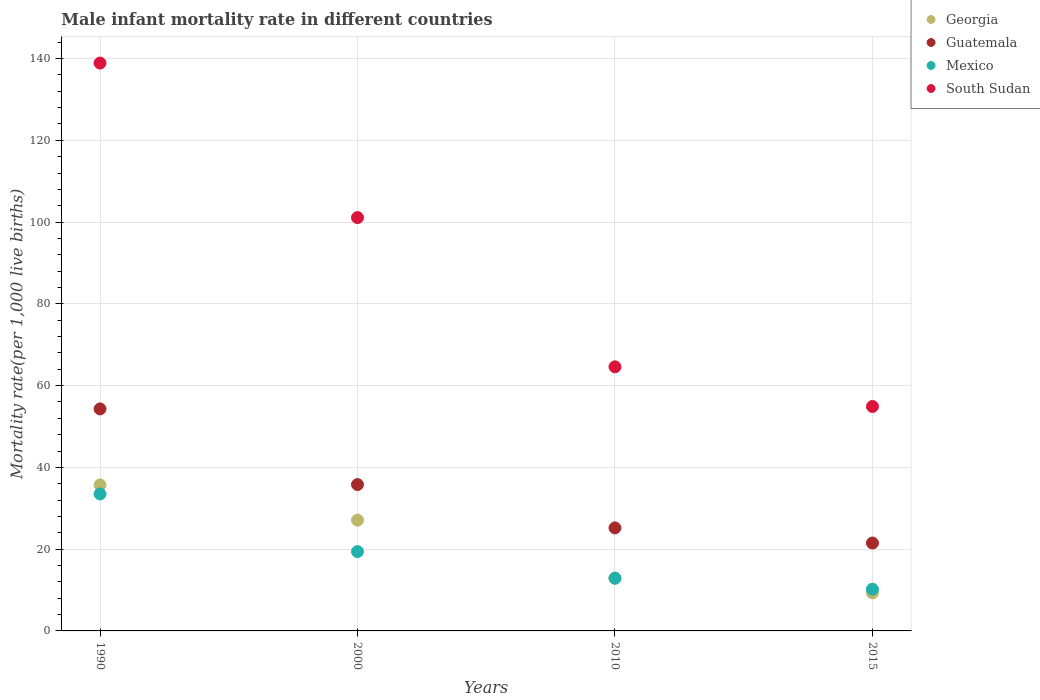What is the male infant mortality rate in Mexico in 1990?
Make the answer very short. 33.5. Across all years, what is the maximum male infant mortality rate in Guatemala?
Your answer should be very brief. 54.3. Across all years, what is the minimum male infant mortality rate in Guatemala?
Your response must be concise. 21.5. In which year was the male infant mortality rate in South Sudan maximum?
Offer a terse response. 1990. In which year was the male infant mortality rate in Mexico minimum?
Offer a very short reply. 2015. What is the total male infant mortality rate in South Sudan in the graph?
Offer a very short reply. 359.5. What is the difference between the male infant mortality rate in Mexico in 2000 and that in 2015?
Offer a terse response. 9.2. What is the difference between the male infant mortality rate in Georgia in 2015 and the male infant mortality rate in Mexico in 1990?
Provide a short and direct response. -24.2. In the year 1990, what is the difference between the male infant mortality rate in Guatemala and male infant mortality rate in Mexico?
Your answer should be compact. 20.8. What is the ratio of the male infant mortality rate in South Sudan in 2000 to that in 2015?
Ensure brevity in your answer.  1.84. Is the male infant mortality rate in Georgia in 1990 less than that in 2000?
Your answer should be very brief. No. Is the difference between the male infant mortality rate in Guatemala in 1990 and 2015 greater than the difference between the male infant mortality rate in Mexico in 1990 and 2015?
Offer a very short reply. Yes. What is the difference between the highest and the second highest male infant mortality rate in Guatemala?
Give a very brief answer. 18.5. What is the difference between the highest and the lowest male infant mortality rate in Guatemala?
Ensure brevity in your answer.  32.8. Is the sum of the male infant mortality rate in Guatemala in 2000 and 2010 greater than the maximum male infant mortality rate in South Sudan across all years?
Keep it short and to the point. No. Is it the case that in every year, the sum of the male infant mortality rate in Mexico and male infant mortality rate in Guatemala  is greater than the sum of male infant mortality rate in South Sudan and male infant mortality rate in Georgia?
Your response must be concise. No. Is it the case that in every year, the sum of the male infant mortality rate in Georgia and male infant mortality rate in Mexico  is greater than the male infant mortality rate in Guatemala?
Keep it short and to the point. No. Does the male infant mortality rate in Georgia monotonically increase over the years?
Ensure brevity in your answer.  No. Is the male infant mortality rate in Georgia strictly greater than the male infant mortality rate in South Sudan over the years?
Provide a succinct answer. No. Is the male infant mortality rate in Georgia strictly less than the male infant mortality rate in Guatemala over the years?
Your answer should be very brief. Yes. How many dotlines are there?
Provide a succinct answer. 4. What is the difference between two consecutive major ticks on the Y-axis?
Provide a succinct answer. 20. Does the graph contain grids?
Provide a short and direct response. Yes. How many legend labels are there?
Your answer should be very brief. 4. What is the title of the graph?
Make the answer very short. Male infant mortality rate in different countries. What is the label or title of the Y-axis?
Ensure brevity in your answer.  Mortality rate(per 1,0 live births). What is the Mortality rate(per 1,000 live births) of Georgia in 1990?
Provide a succinct answer. 35.7. What is the Mortality rate(per 1,000 live births) of Guatemala in 1990?
Provide a succinct answer. 54.3. What is the Mortality rate(per 1,000 live births) in Mexico in 1990?
Keep it short and to the point. 33.5. What is the Mortality rate(per 1,000 live births) in South Sudan in 1990?
Your answer should be very brief. 138.9. What is the Mortality rate(per 1,000 live births) in Georgia in 2000?
Your response must be concise. 27.1. What is the Mortality rate(per 1,000 live births) of Guatemala in 2000?
Give a very brief answer. 35.8. What is the Mortality rate(per 1,000 live births) of Mexico in 2000?
Provide a succinct answer. 19.4. What is the Mortality rate(per 1,000 live births) in South Sudan in 2000?
Your response must be concise. 101.1. What is the Mortality rate(per 1,000 live births) in Guatemala in 2010?
Your answer should be very brief. 25.2. What is the Mortality rate(per 1,000 live births) of South Sudan in 2010?
Make the answer very short. 64.6. What is the Mortality rate(per 1,000 live births) in Georgia in 2015?
Offer a terse response. 9.3. What is the Mortality rate(per 1,000 live births) of Guatemala in 2015?
Provide a succinct answer. 21.5. What is the Mortality rate(per 1,000 live births) of South Sudan in 2015?
Make the answer very short. 54.9. Across all years, what is the maximum Mortality rate(per 1,000 live births) of Georgia?
Ensure brevity in your answer.  35.7. Across all years, what is the maximum Mortality rate(per 1,000 live births) in Guatemala?
Your answer should be compact. 54.3. Across all years, what is the maximum Mortality rate(per 1,000 live births) in Mexico?
Your answer should be very brief. 33.5. Across all years, what is the maximum Mortality rate(per 1,000 live births) of South Sudan?
Your answer should be very brief. 138.9. Across all years, what is the minimum Mortality rate(per 1,000 live births) of South Sudan?
Provide a short and direct response. 54.9. What is the total Mortality rate(per 1,000 live births) of Georgia in the graph?
Keep it short and to the point. 85. What is the total Mortality rate(per 1,000 live births) of Guatemala in the graph?
Ensure brevity in your answer.  136.8. What is the total Mortality rate(per 1,000 live births) in South Sudan in the graph?
Ensure brevity in your answer.  359.5. What is the difference between the Mortality rate(per 1,000 live births) of Mexico in 1990 and that in 2000?
Keep it short and to the point. 14.1. What is the difference between the Mortality rate(per 1,000 live births) in South Sudan in 1990 and that in 2000?
Keep it short and to the point. 37.8. What is the difference between the Mortality rate(per 1,000 live births) of Georgia in 1990 and that in 2010?
Provide a succinct answer. 22.8. What is the difference between the Mortality rate(per 1,000 live births) in Guatemala in 1990 and that in 2010?
Offer a very short reply. 29.1. What is the difference between the Mortality rate(per 1,000 live births) in Mexico in 1990 and that in 2010?
Provide a short and direct response. 20.6. What is the difference between the Mortality rate(per 1,000 live births) in South Sudan in 1990 and that in 2010?
Offer a terse response. 74.3. What is the difference between the Mortality rate(per 1,000 live births) of Georgia in 1990 and that in 2015?
Your response must be concise. 26.4. What is the difference between the Mortality rate(per 1,000 live births) of Guatemala in 1990 and that in 2015?
Offer a very short reply. 32.8. What is the difference between the Mortality rate(per 1,000 live births) of Mexico in 1990 and that in 2015?
Your response must be concise. 23.3. What is the difference between the Mortality rate(per 1,000 live births) in South Sudan in 1990 and that in 2015?
Keep it short and to the point. 84. What is the difference between the Mortality rate(per 1,000 live births) in Guatemala in 2000 and that in 2010?
Offer a terse response. 10.6. What is the difference between the Mortality rate(per 1,000 live births) in South Sudan in 2000 and that in 2010?
Offer a very short reply. 36.5. What is the difference between the Mortality rate(per 1,000 live births) in Mexico in 2000 and that in 2015?
Provide a short and direct response. 9.2. What is the difference between the Mortality rate(per 1,000 live births) in South Sudan in 2000 and that in 2015?
Your answer should be very brief. 46.2. What is the difference between the Mortality rate(per 1,000 live births) of Georgia in 2010 and that in 2015?
Provide a succinct answer. 3.6. What is the difference between the Mortality rate(per 1,000 live births) of Guatemala in 2010 and that in 2015?
Offer a terse response. 3.7. What is the difference between the Mortality rate(per 1,000 live births) in Mexico in 2010 and that in 2015?
Keep it short and to the point. 2.7. What is the difference between the Mortality rate(per 1,000 live births) of Georgia in 1990 and the Mortality rate(per 1,000 live births) of Mexico in 2000?
Keep it short and to the point. 16.3. What is the difference between the Mortality rate(per 1,000 live births) of Georgia in 1990 and the Mortality rate(per 1,000 live births) of South Sudan in 2000?
Offer a very short reply. -65.4. What is the difference between the Mortality rate(per 1,000 live births) of Guatemala in 1990 and the Mortality rate(per 1,000 live births) of Mexico in 2000?
Offer a very short reply. 34.9. What is the difference between the Mortality rate(per 1,000 live births) in Guatemala in 1990 and the Mortality rate(per 1,000 live births) in South Sudan in 2000?
Your answer should be compact. -46.8. What is the difference between the Mortality rate(per 1,000 live births) in Mexico in 1990 and the Mortality rate(per 1,000 live births) in South Sudan in 2000?
Make the answer very short. -67.6. What is the difference between the Mortality rate(per 1,000 live births) in Georgia in 1990 and the Mortality rate(per 1,000 live births) in Mexico in 2010?
Your answer should be compact. 22.8. What is the difference between the Mortality rate(per 1,000 live births) of Georgia in 1990 and the Mortality rate(per 1,000 live births) of South Sudan in 2010?
Keep it short and to the point. -28.9. What is the difference between the Mortality rate(per 1,000 live births) in Guatemala in 1990 and the Mortality rate(per 1,000 live births) in Mexico in 2010?
Your response must be concise. 41.4. What is the difference between the Mortality rate(per 1,000 live births) in Guatemala in 1990 and the Mortality rate(per 1,000 live births) in South Sudan in 2010?
Your answer should be very brief. -10.3. What is the difference between the Mortality rate(per 1,000 live births) of Mexico in 1990 and the Mortality rate(per 1,000 live births) of South Sudan in 2010?
Provide a short and direct response. -31.1. What is the difference between the Mortality rate(per 1,000 live births) in Georgia in 1990 and the Mortality rate(per 1,000 live births) in Guatemala in 2015?
Your answer should be very brief. 14.2. What is the difference between the Mortality rate(per 1,000 live births) in Georgia in 1990 and the Mortality rate(per 1,000 live births) in South Sudan in 2015?
Keep it short and to the point. -19.2. What is the difference between the Mortality rate(per 1,000 live births) in Guatemala in 1990 and the Mortality rate(per 1,000 live births) in Mexico in 2015?
Your response must be concise. 44.1. What is the difference between the Mortality rate(per 1,000 live births) in Guatemala in 1990 and the Mortality rate(per 1,000 live births) in South Sudan in 2015?
Ensure brevity in your answer.  -0.6. What is the difference between the Mortality rate(per 1,000 live births) of Mexico in 1990 and the Mortality rate(per 1,000 live births) of South Sudan in 2015?
Provide a succinct answer. -21.4. What is the difference between the Mortality rate(per 1,000 live births) in Georgia in 2000 and the Mortality rate(per 1,000 live births) in South Sudan in 2010?
Your answer should be compact. -37.5. What is the difference between the Mortality rate(per 1,000 live births) in Guatemala in 2000 and the Mortality rate(per 1,000 live births) in Mexico in 2010?
Your response must be concise. 22.9. What is the difference between the Mortality rate(per 1,000 live births) of Guatemala in 2000 and the Mortality rate(per 1,000 live births) of South Sudan in 2010?
Keep it short and to the point. -28.8. What is the difference between the Mortality rate(per 1,000 live births) in Mexico in 2000 and the Mortality rate(per 1,000 live births) in South Sudan in 2010?
Provide a short and direct response. -45.2. What is the difference between the Mortality rate(per 1,000 live births) in Georgia in 2000 and the Mortality rate(per 1,000 live births) in South Sudan in 2015?
Your response must be concise. -27.8. What is the difference between the Mortality rate(per 1,000 live births) in Guatemala in 2000 and the Mortality rate(per 1,000 live births) in Mexico in 2015?
Offer a very short reply. 25.6. What is the difference between the Mortality rate(per 1,000 live births) of Guatemala in 2000 and the Mortality rate(per 1,000 live births) of South Sudan in 2015?
Your answer should be very brief. -19.1. What is the difference between the Mortality rate(per 1,000 live births) of Mexico in 2000 and the Mortality rate(per 1,000 live births) of South Sudan in 2015?
Offer a very short reply. -35.5. What is the difference between the Mortality rate(per 1,000 live births) in Georgia in 2010 and the Mortality rate(per 1,000 live births) in Guatemala in 2015?
Keep it short and to the point. -8.6. What is the difference between the Mortality rate(per 1,000 live births) in Georgia in 2010 and the Mortality rate(per 1,000 live births) in South Sudan in 2015?
Provide a short and direct response. -42. What is the difference between the Mortality rate(per 1,000 live births) of Guatemala in 2010 and the Mortality rate(per 1,000 live births) of South Sudan in 2015?
Your response must be concise. -29.7. What is the difference between the Mortality rate(per 1,000 live births) in Mexico in 2010 and the Mortality rate(per 1,000 live births) in South Sudan in 2015?
Provide a short and direct response. -42. What is the average Mortality rate(per 1,000 live births) in Georgia per year?
Offer a terse response. 21.25. What is the average Mortality rate(per 1,000 live births) of Guatemala per year?
Provide a short and direct response. 34.2. What is the average Mortality rate(per 1,000 live births) of Mexico per year?
Your response must be concise. 19. What is the average Mortality rate(per 1,000 live births) of South Sudan per year?
Your answer should be very brief. 89.88. In the year 1990, what is the difference between the Mortality rate(per 1,000 live births) in Georgia and Mortality rate(per 1,000 live births) in Guatemala?
Give a very brief answer. -18.6. In the year 1990, what is the difference between the Mortality rate(per 1,000 live births) in Georgia and Mortality rate(per 1,000 live births) in Mexico?
Your response must be concise. 2.2. In the year 1990, what is the difference between the Mortality rate(per 1,000 live births) in Georgia and Mortality rate(per 1,000 live births) in South Sudan?
Offer a very short reply. -103.2. In the year 1990, what is the difference between the Mortality rate(per 1,000 live births) of Guatemala and Mortality rate(per 1,000 live births) of Mexico?
Your answer should be compact. 20.8. In the year 1990, what is the difference between the Mortality rate(per 1,000 live births) in Guatemala and Mortality rate(per 1,000 live births) in South Sudan?
Ensure brevity in your answer.  -84.6. In the year 1990, what is the difference between the Mortality rate(per 1,000 live births) in Mexico and Mortality rate(per 1,000 live births) in South Sudan?
Give a very brief answer. -105.4. In the year 2000, what is the difference between the Mortality rate(per 1,000 live births) of Georgia and Mortality rate(per 1,000 live births) of Guatemala?
Provide a short and direct response. -8.7. In the year 2000, what is the difference between the Mortality rate(per 1,000 live births) of Georgia and Mortality rate(per 1,000 live births) of South Sudan?
Give a very brief answer. -74. In the year 2000, what is the difference between the Mortality rate(per 1,000 live births) in Guatemala and Mortality rate(per 1,000 live births) in South Sudan?
Give a very brief answer. -65.3. In the year 2000, what is the difference between the Mortality rate(per 1,000 live births) in Mexico and Mortality rate(per 1,000 live births) in South Sudan?
Ensure brevity in your answer.  -81.7. In the year 2010, what is the difference between the Mortality rate(per 1,000 live births) in Georgia and Mortality rate(per 1,000 live births) in Guatemala?
Keep it short and to the point. -12.3. In the year 2010, what is the difference between the Mortality rate(per 1,000 live births) of Georgia and Mortality rate(per 1,000 live births) of South Sudan?
Your answer should be compact. -51.7. In the year 2010, what is the difference between the Mortality rate(per 1,000 live births) in Guatemala and Mortality rate(per 1,000 live births) in Mexico?
Offer a terse response. 12.3. In the year 2010, what is the difference between the Mortality rate(per 1,000 live births) of Guatemala and Mortality rate(per 1,000 live births) of South Sudan?
Your response must be concise. -39.4. In the year 2010, what is the difference between the Mortality rate(per 1,000 live births) in Mexico and Mortality rate(per 1,000 live births) in South Sudan?
Offer a very short reply. -51.7. In the year 2015, what is the difference between the Mortality rate(per 1,000 live births) of Georgia and Mortality rate(per 1,000 live births) of Guatemala?
Ensure brevity in your answer.  -12.2. In the year 2015, what is the difference between the Mortality rate(per 1,000 live births) of Georgia and Mortality rate(per 1,000 live births) of South Sudan?
Keep it short and to the point. -45.6. In the year 2015, what is the difference between the Mortality rate(per 1,000 live births) of Guatemala and Mortality rate(per 1,000 live births) of Mexico?
Ensure brevity in your answer.  11.3. In the year 2015, what is the difference between the Mortality rate(per 1,000 live births) of Guatemala and Mortality rate(per 1,000 live births) of South Sudan?
Offer a terse response. -33.4. In the year 2015, what is the difference between the Mortality rate(per 1,000 live births) in Mexico and Mortality rate(per 1,000 live births) in South Sudan?
Your response must be concise. -44.7. What is the ratio of the Mortality rate(per 1,000 live births) of Georgia in 1990 to that in 2000?
Your answer should be very brief. 1.32. What is the ratio of the Mortality rate(per 1,000 live births) of Guatemala in 1990 to that in 2000?
Your answer should be compact. 1.52. What is the ratio of the Mortality rate(per 1,000 live births) in Mexico in 1990 to that in 2000?
Offer a very short reply. 1.73. What is the ratio of the Mortality rate(per 1,000 live births) in South Sudan in 1990 to that in 2000?
Offer a very short reply. 1.37. What is the ratio of the Mortality rate(per 1,000 live births) of Georgia in 1990 to that in 2010?
Keep it short and to the point. 2.77. What is the ratio of the Mortality rate(per 1,000 live births) in Guatemala in 1990 to that in 2010?
Give a very brief answer. 2.15. What is the ratio of the Mortality rate(per 1,000 live births) of Mexico in 1990 to that in 2010?
Ensure brevity in your answer.  2.6. What is the ratio of the Mortality rate(per 1,000 live births) in South Sudan in 1990 to that in 2010?
Your response must be concise. 2.15. What is the ratio of the Mortality rate(per 1,000 live births) of Georgia in 1990 to that in 2015?
Your answer should be compact. 3.84. What is the ratio of the Mortality rate(per 1,000 live births) in Guatemala in 1990 to that in 2015?
Your answer should be compact. 2.53. What is the ratio of the Mortality rate(per 1,000 live births) of Mexico in 1990 to that in 2015?
Make the answer very short. 3.28. What is the ratio of the Mortality rate(per 1,000 live births) of South Sudan in 1990 to that in 2015?
Make the answer very short. 2.53. What is the ratio of the Mortality rate(per 1,000 live births) of Georgia in 2000 to that in 2010?
Your answer should be compact. 2.1. What is the ratio of the Mortality rate(per 1,000 live births) in Guatemala in 2000 to that in 2010?
Your answer should be very brief. 1.42. What is the ratio of the Mortality rate(per 1,000 live births) in Mexico in 2000 to that in 2010?
Ensure brevity in your answer.  1.5. What is the ratio of the Mortality rate(per 1,000 live births) in South Sudan in 2000 to that in 2010?
Ensure brevity in your answer.  1.56. What is the ratio of the Mortality rate(per 1,000 live births) of Georgia in 2000 to that in 2015?
Keep it short and to the point. 2.91. What is the ratio of the Mortality rate(per 1,000 live births) of Guatemala in 2000 to that in 2015?
Keep it short and to the point. 1.67. What is the ratio of the Mortality rate(per 1,000 live births) in Mexico in 2000 to that in 2015?
Keep it short and to the point. 1.9. What is the ratio of the Mortality rate(per 1,000 live births) of South Sudan in 2000 to that in 2015?
Your answer should be very brief. 1.84. What is the ratio of the Mortality rate(per 1,000 live births) of Georgia in 2010 to that in 2015?
Offer a terse response. 1.39. What is the ratio of the Mortality rate(per 1,000 live births) in Guatemala in 2010 to that in 2015?
Your answer should be very brief. 1.17. What is the ratio of the Mortality rate(per 1,000 live births) in Mexico in 2010 to that in 2015?
Keep it short and to the point. 1.26. What is the ratio of the Mortality rate(per 1,000 live births) of South Sudan in 2010 to that in 2015?
Ensure brevity in your answer.  1.18. What is the difference between the highest and the second highest Mortality rate(per 1,000 live births) in Georgia?
Your response must be concise. 8.6. What is the difference between the highest and the second highest Mortality rate(per 1,000 live births) of South Sudan?
Provide a succinct answer. 37.8. What is the difference between the highest and the lowest Mortality rate(per 1,000 live births) of Georgia?
Your answer should be very brief. 26.4. What is the difference between the highest and the lowest Mortality rate(per 1,000 live births) of Guatemala?
Make the answer very short. 32.8. What is the difference between the highest and the lowest Mortality rate(per 1,000 live births) of Mexico?
Provide a succinct answer. 23.3. 